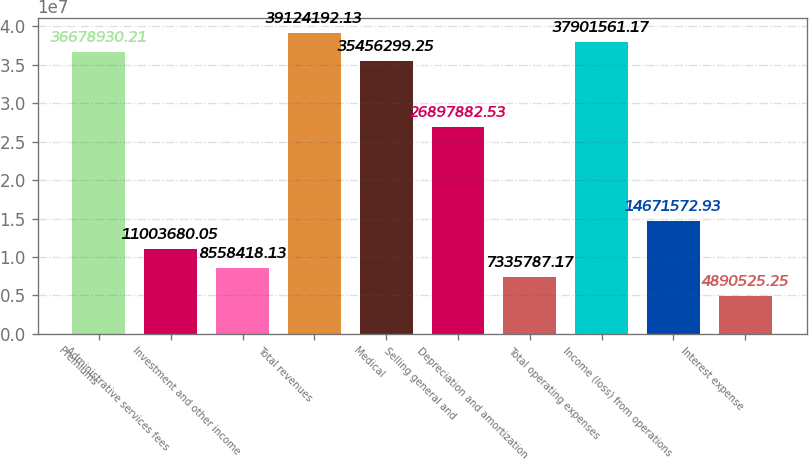Convert chart. <chart><loc_0><loc_0><loc_500><loc_500><bar_chart><fcel>Premiums<fcel>Administrative services fees<fcel>Investment and other income<fcel>Total revenues<fcel>Medical<fcel>Selling general and<fcel>Depreciation and amortization<fcel>Total operating expenses<fcel>Income (loss) from operations<fcel>Interest expense<nl><fcel>3.66789e+07<fcel>1.10037e+07<fcel>8.55842e+06<fcel>3.91242e+07<fcel>3.54563e+07<fcel>2.68979e+07<fcel>7.33579e+06<fcel>3.79016e+07<fcel>1.46716e+07<fcel>4.89053e+06<nl></chart> 